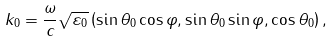<formula> <loc_0><loc_0><loc_500><loc_500>k _ { 0 } = \frac { \omega } { c } \sqrt { \varepsilon _ { 0 } } \left ( \sin \theta _ { 0 } \cos \varphi , \sin \theta _ { 0 } \sin \varphi , \cos \theta _ { 0 } \right ) ,</formula> 